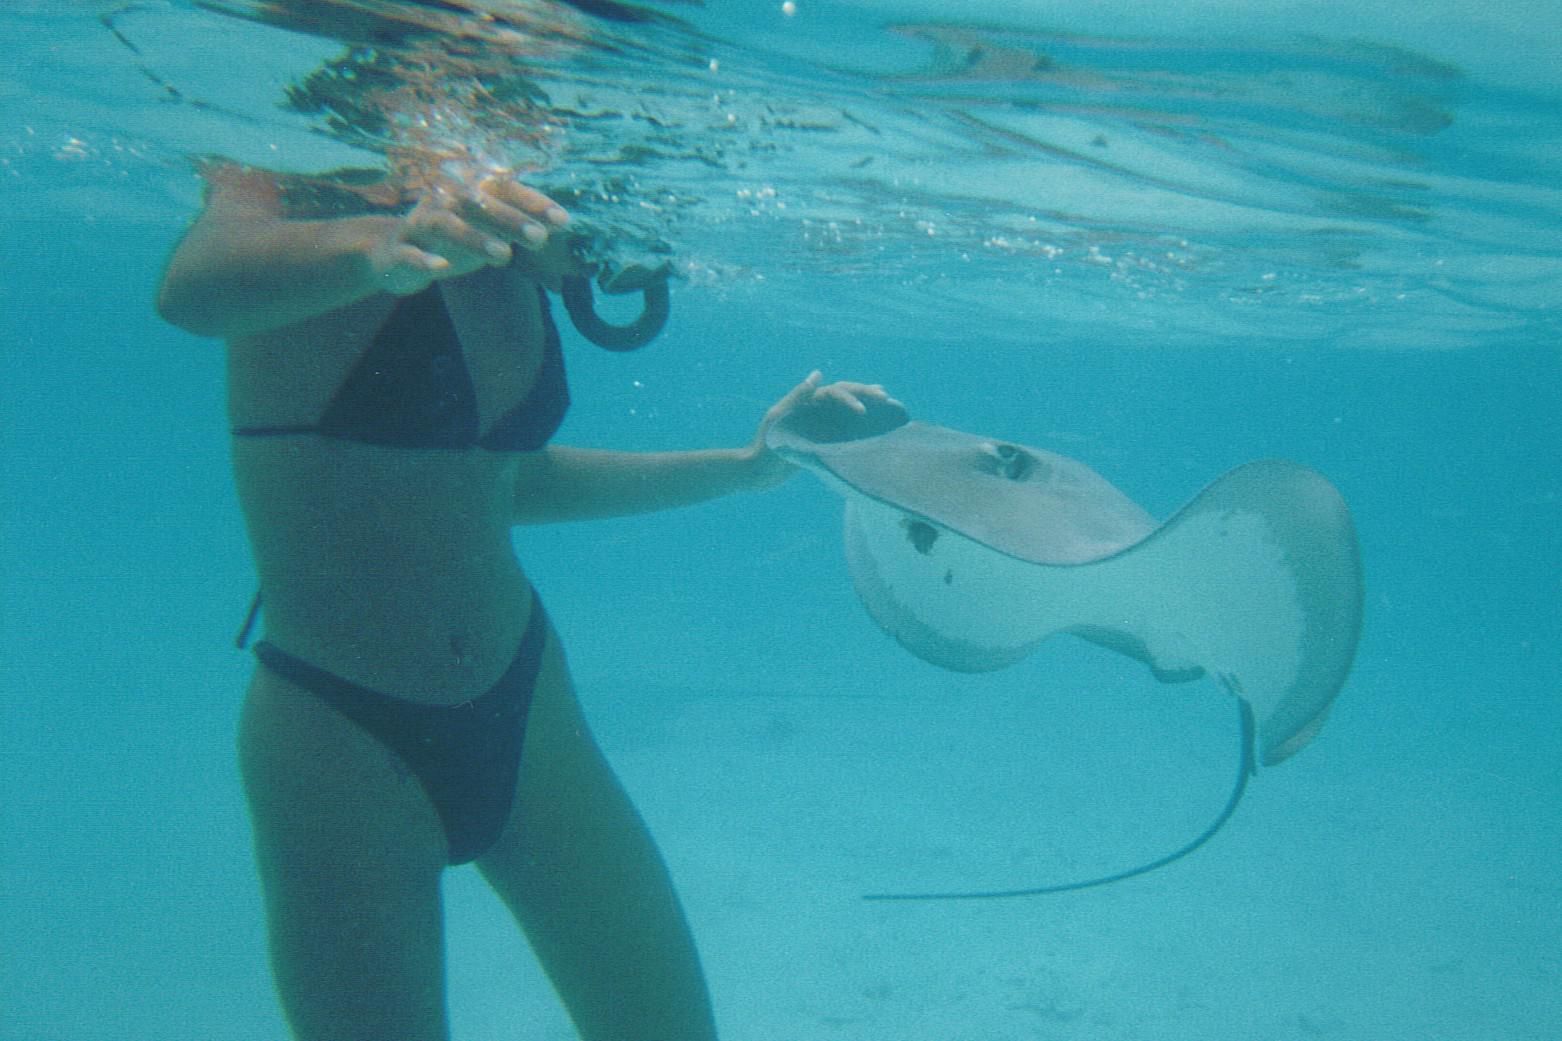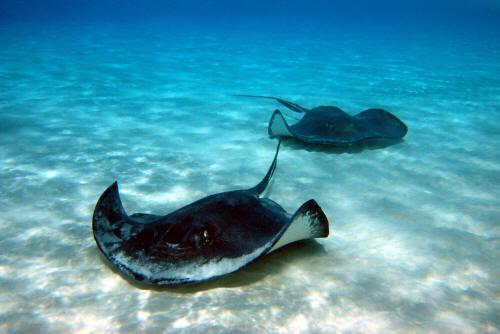The first image is the image on the left, the second image is the image on the right. For the images displayed, is the sentence "The woman in the left image is wearing a bikini; we can clearly see most of her bathing suit." factually correct? Answer yes or no. Yes. The first image is the image on the left, the second image is the image on the right. For the images displayed, is the sentence "A woman in a bikini is in the water next to a gray stingray." factually correct? Answer yes or no. Yes. 